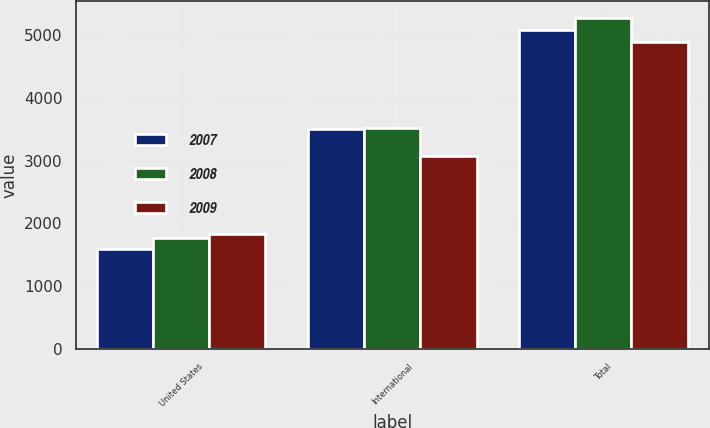<chart> <loc_0><loc_0><loc_500><loc_500><stacked_bar_chart><ecel><fcel>United States<fcel>International<fcel>Total<nl><fcel>2007<fcel>1584.9<fcel>3498.7<fcel>5083.6<nl><fcel>2008<fcel>1760<fcel>3522<fcel>5282<nl><fcel>2009<fcel>1825.3<fcel>3074.9<fcel>4900.2<nl></chart> 